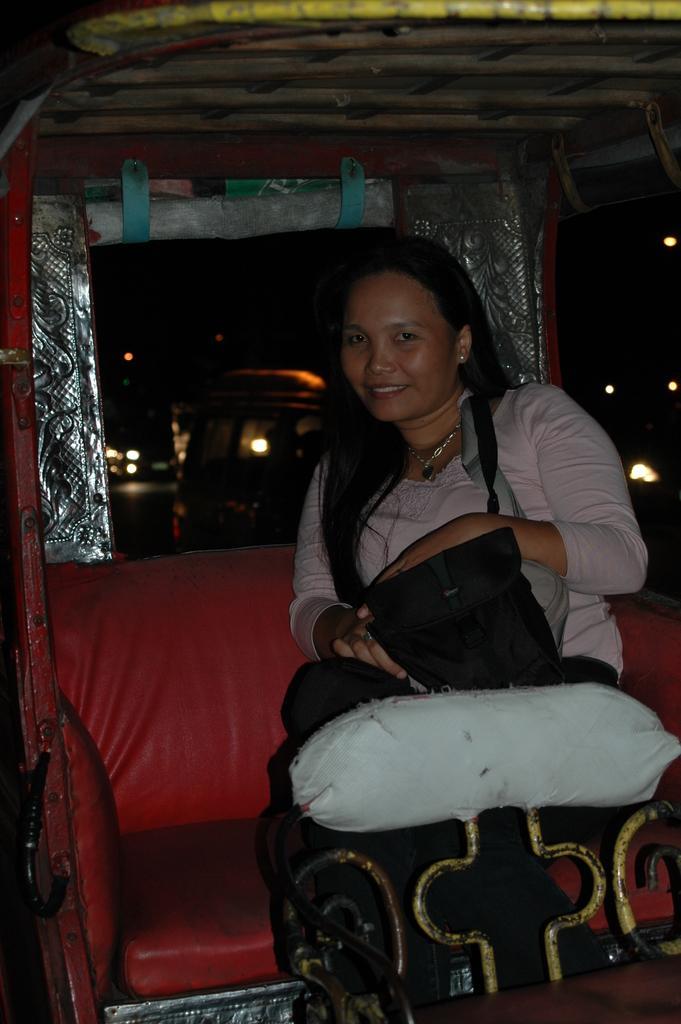Please provide a concise description of this image. In this image in the foreground there is one vehicle, in that vehicle there is one woman who is sitting and she is holding some bags. In the background there are some vehicles and lights. 